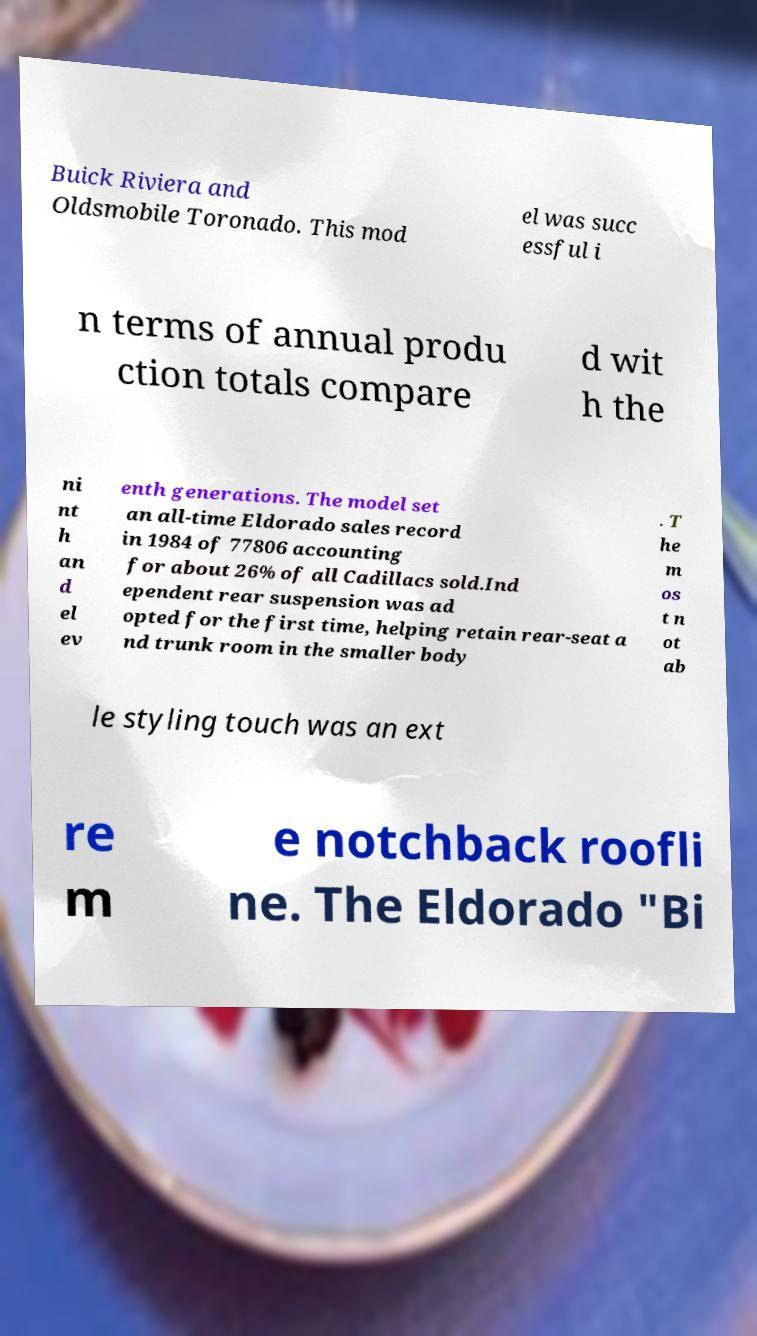Could you extract and type out the text from this image? Buick Riviera and Oldsmobile Toronado. This mod el was succ essful i n terms of annual produ ction totals compare d wit h the ni nt h an d el ev enth generations. The model set an all-time Eldorado sales record in 1984 of 77806 accounting for about 26% of all Cadillacs sold.Ind ependent rear suspension was ad opted for the first time, helping retain rear-seat a nd trunk room in the smaller body . T he m os t n ot ab le styling touch was an ext re m e notchback roofli ne. The Eldorado "Bi 